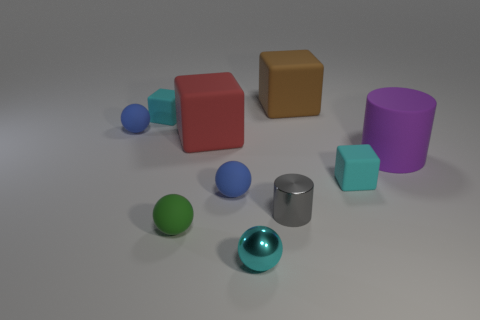Subtract all big brown rubber blocks. How many blocks are left? 3 Subtract 2 spheres. How many spheres are left? 2 Subtract all brown cubes. How many cubes are left? 3 Subtract all cubes. How many objects are left? 6 Subtract all green cylinders. Subtract all cyan blocks. How many cylinders are left? 2 Subtract all gray cylinders. How many brown blocks are left? 1 Subtract all gray rubber spheres. Subtract all spheres. How many objects are left? 6 Add 6 cyan shiny objects. How many cyan shiny objects are left? 7 Add 6 small blue rubber balls. How many small blue rubber balls exist? 8 Subtract 0 blue cubes. How many objects are left? 10 